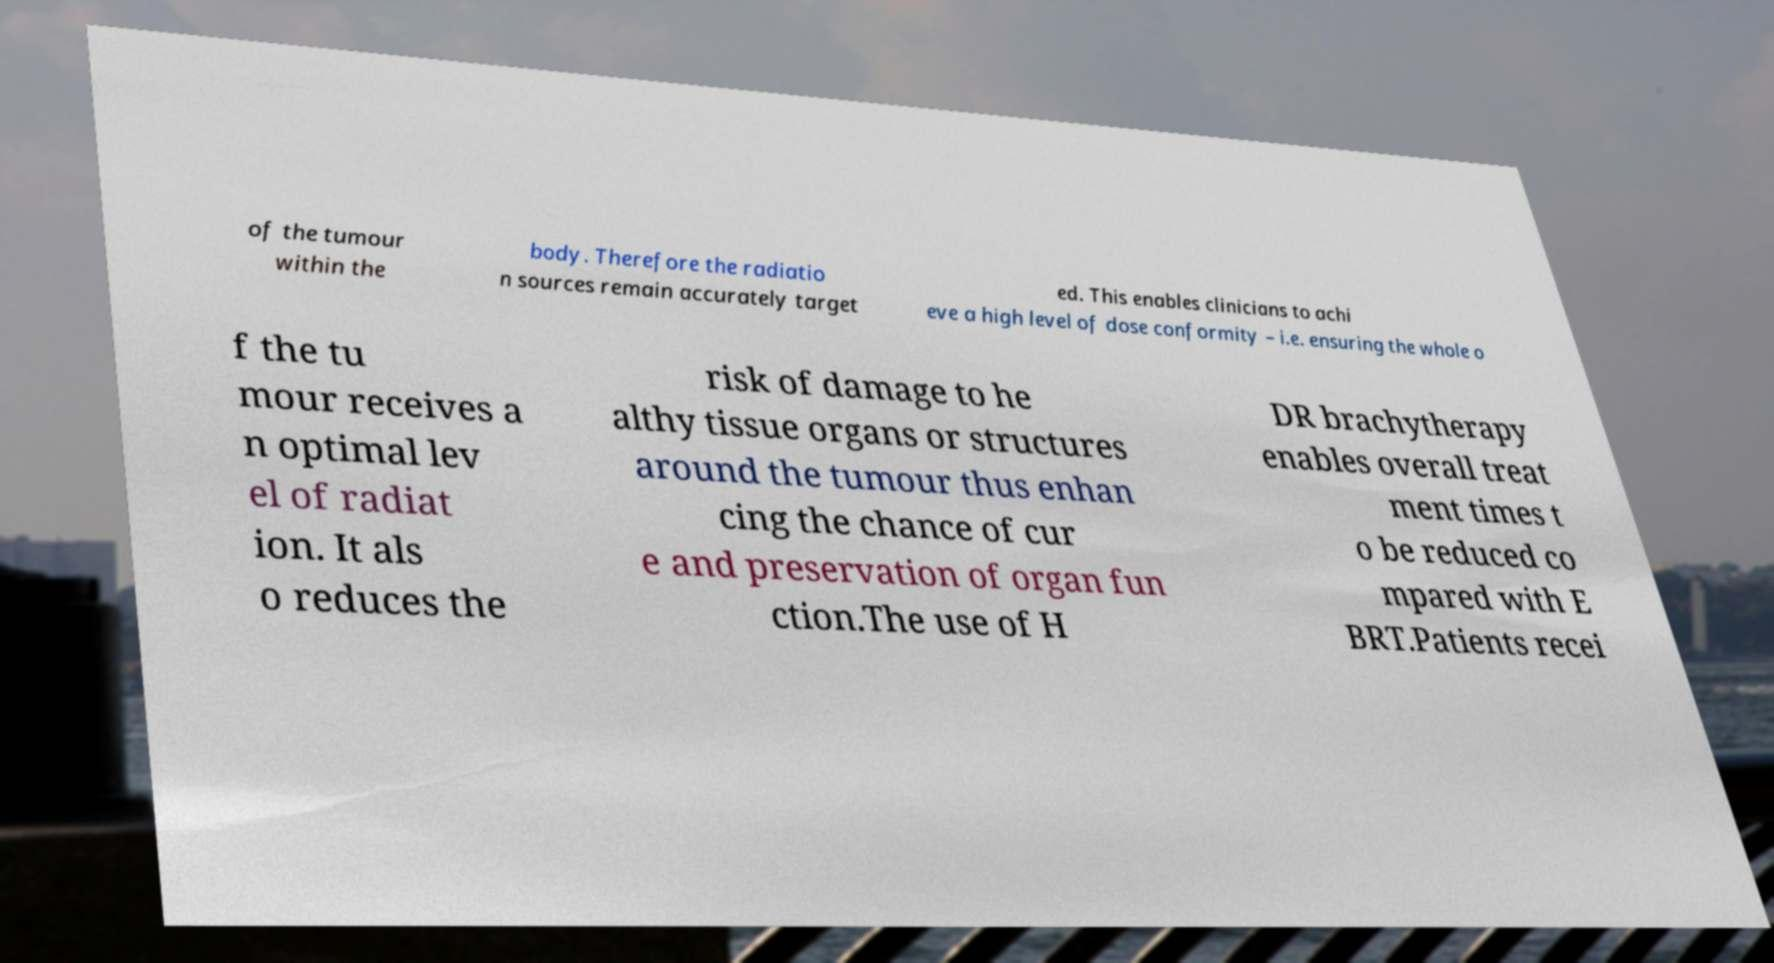What messages or text are displayed in this image? I need them in a readable, typed format. of the tumour within the body. Therefore the radiatio n sources remain accurately target ed. This enables clinicians to achi eve a high level of dose conformity – i.e. ensuring the whole o f the tu mour receives a n optimal lev el of radiat ion. It als o reduces the risk of damage to he althy tissue organs or structures around the tumour thus enhan cing the chance of cur e and preservation of organ fun ction.The use of H DR brachytherapy enables overall treat ment times t o be reduced co mpared with E BRT.Patients recei 